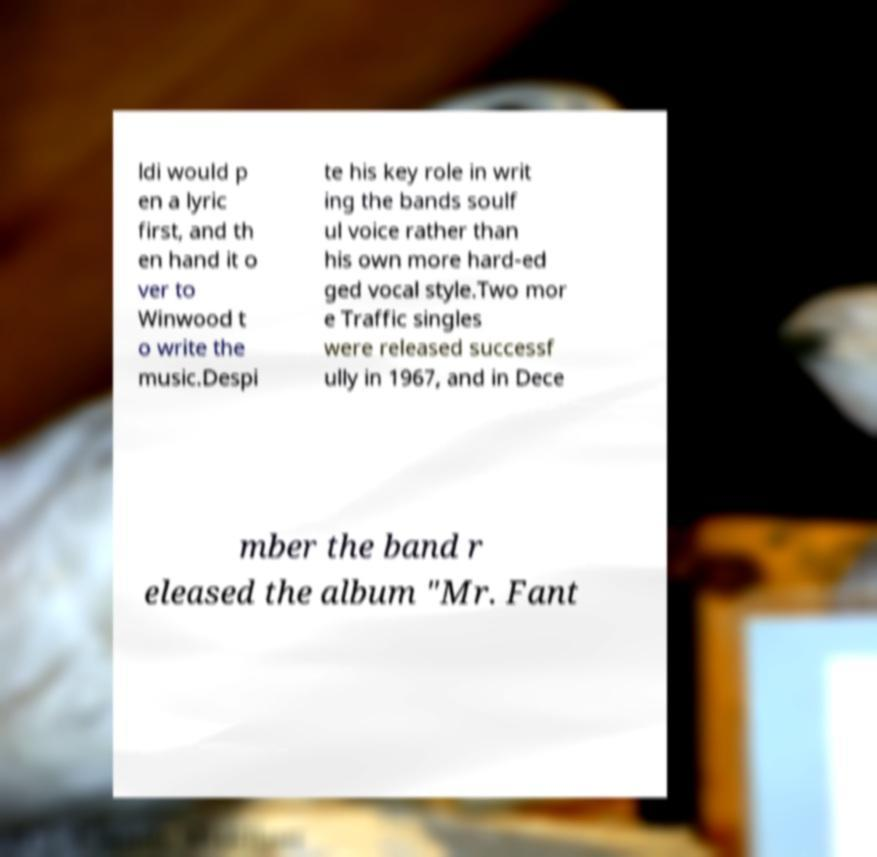For documentation purposes, I need the text within this image transcribed. Could you provide that? ldi would p en a lyric first, and th en hand it o ver to Winwood t o write the music.Despi te his key role in writ ing the bands soulf ul voice rather than his own more hard-ed ged vocal style.Two mor e Traffic singles were released successf ully in 1967, and in Dece mber the band r eleased the album "Mr. Fant 